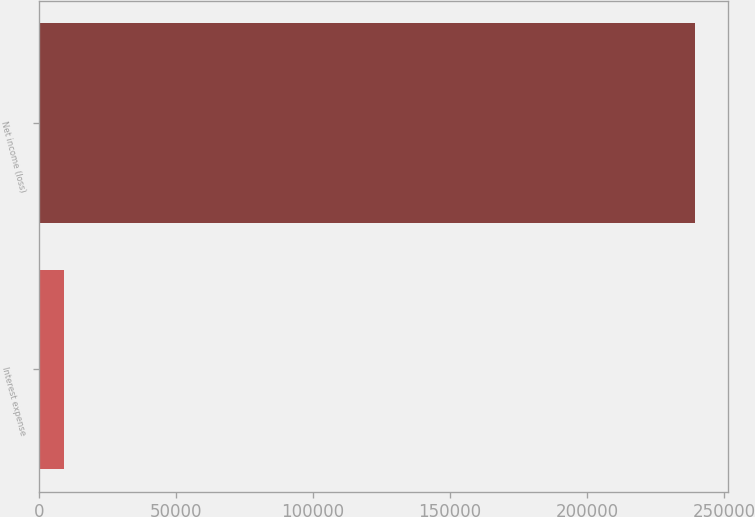Convert chart to OTSL. <chart><loc_0><loc_0><loc_500><loc_500><bar_chart><fcel>Interest expense<fcel>Net income (loss)<nl><fcel>9153<fcel>239457<nl></chart> 